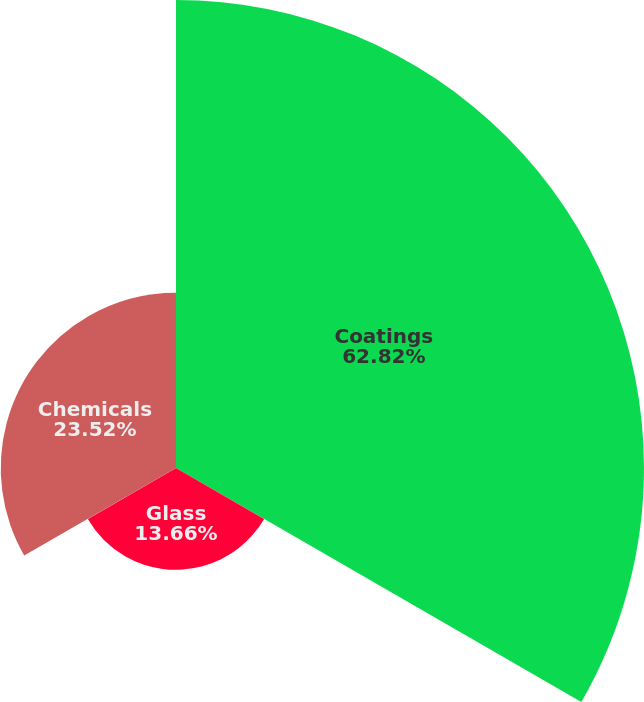<chart> <loc_0><loc_0><loc_500><loc_500><pie_chart><fcel>Coatings<fcel>Glass<fcel>Chemicals<nl><fcel>62.81%<fcel>13.66%<fcel>23.52%<nl></chart> 